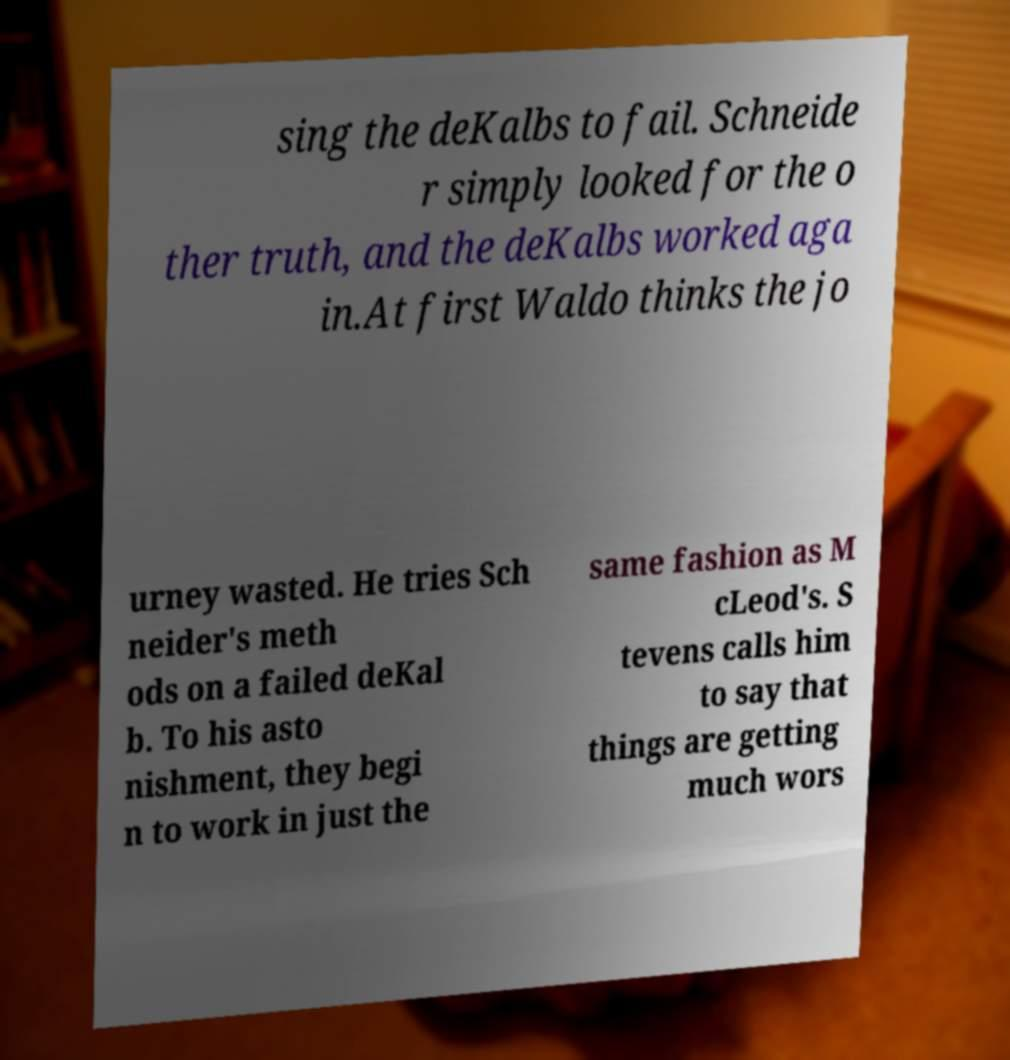For documentation purposes, I need the text within this image transcribed. Could you provide that? sing the deKalbs to fail. Schneide r simply looked for the o ther truth, and the deKalbs worked aga in.At first Waldo thinks the jo urney wasted. He tries Sch neider's meth ods on a failed deKal b. To his asto nishment, they begi n to work in just the same fashion as M cLeod's. S tevens calls him to say that things are getting much wors 